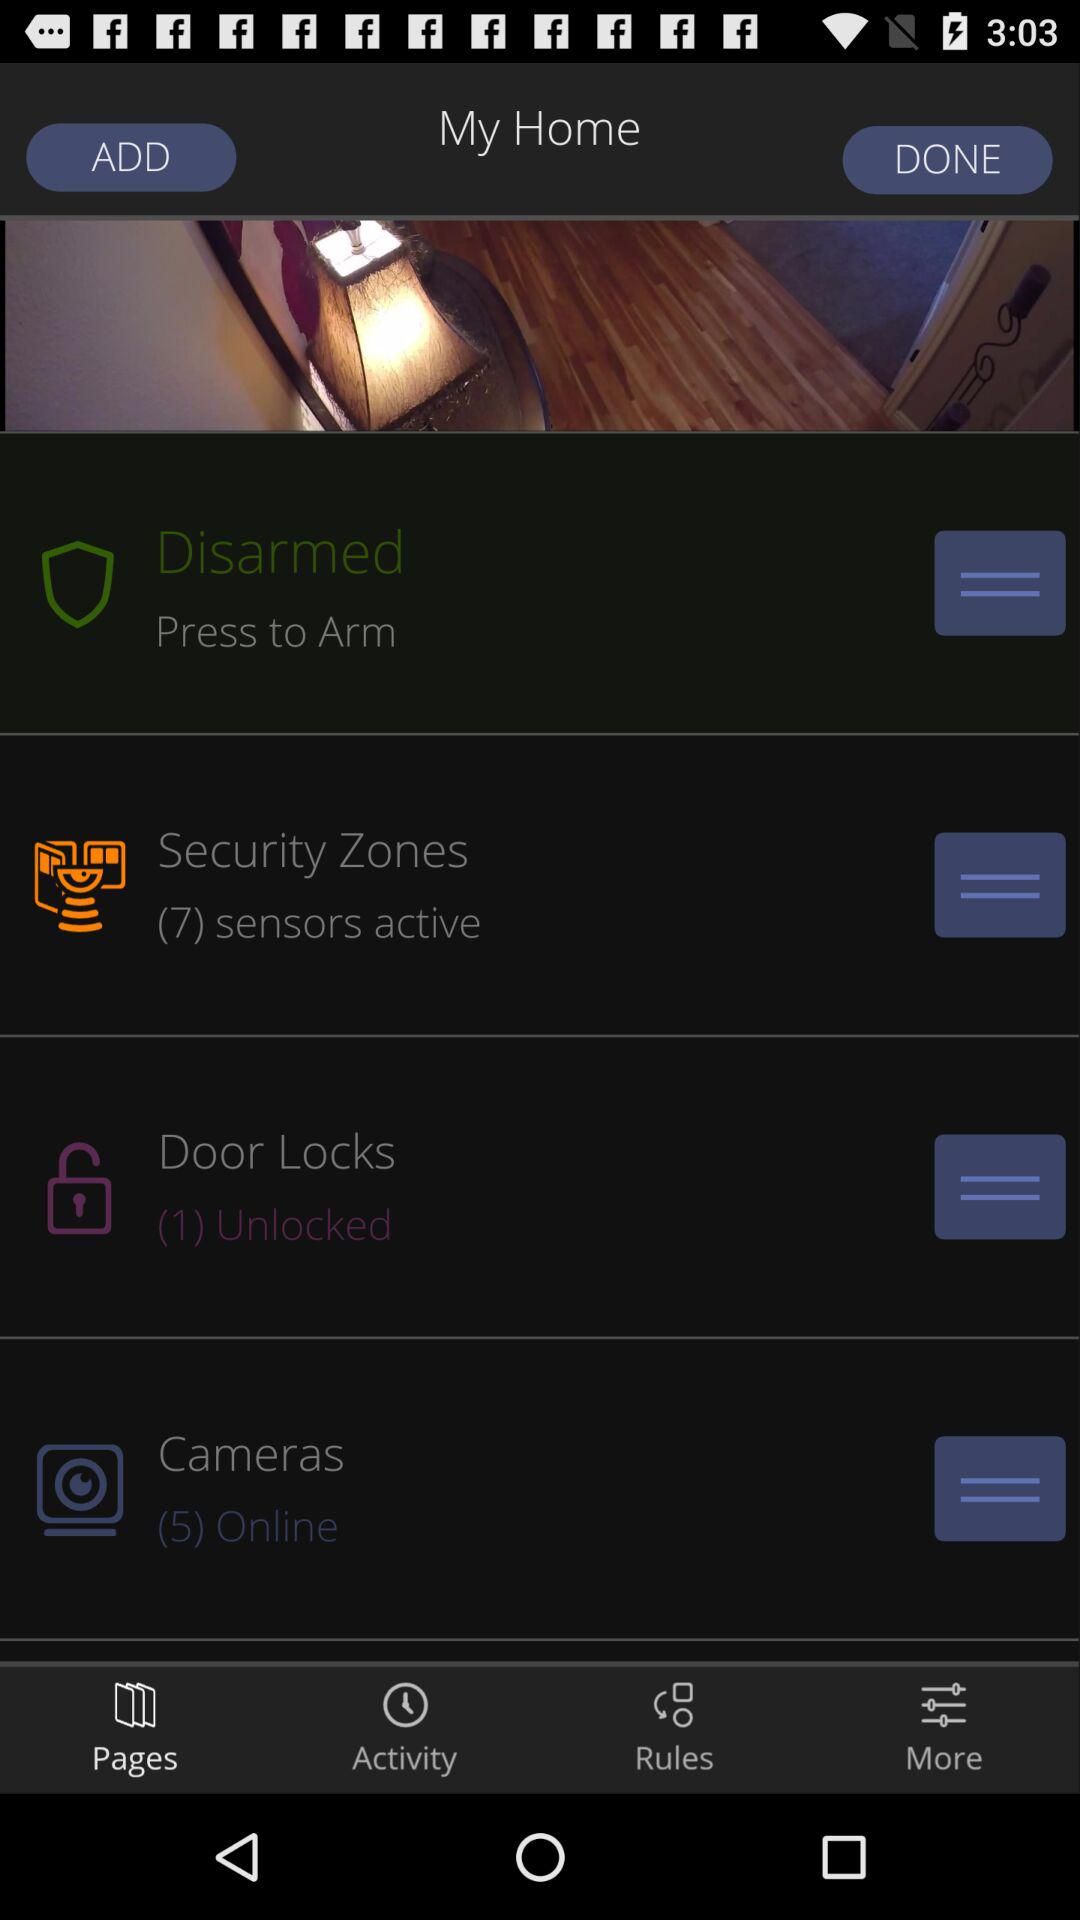How many active sensors are there in "Security Zones"? There are 7 active sensors. 